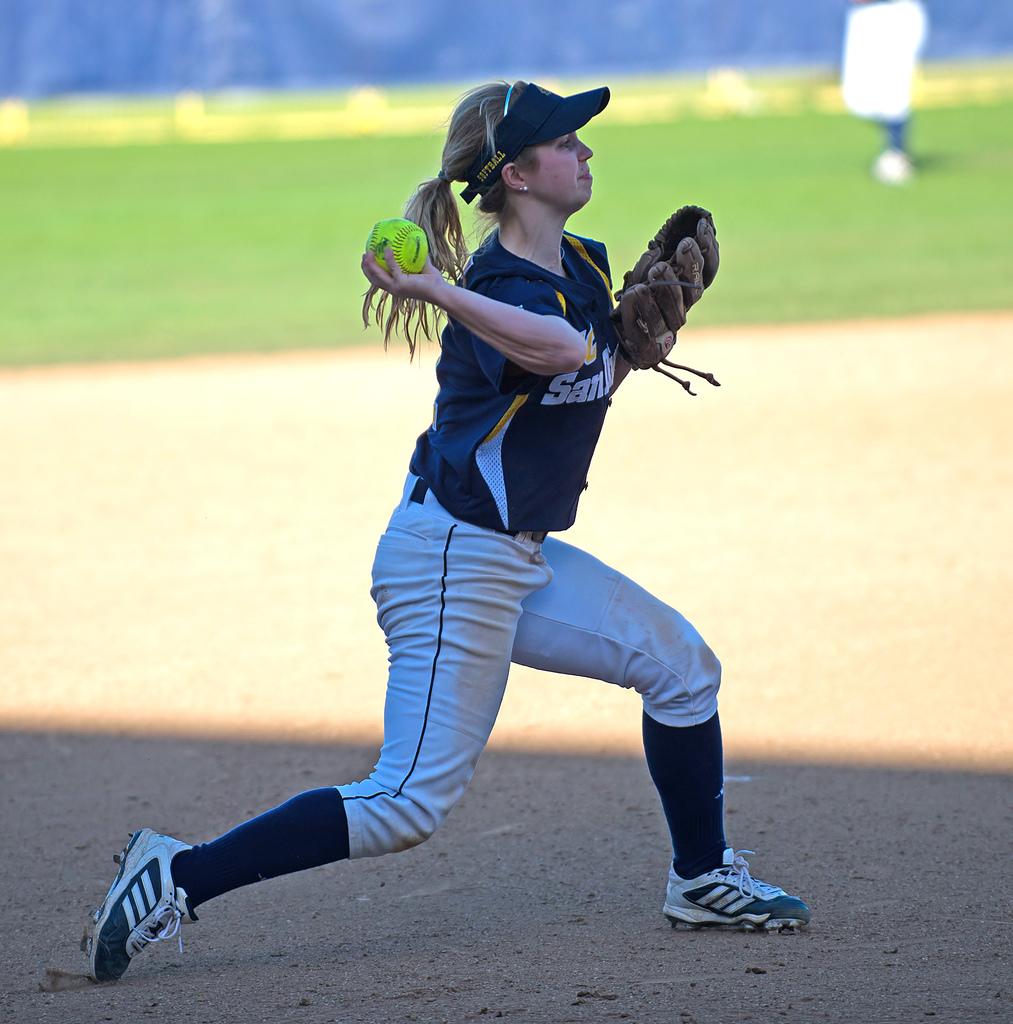What is this girl playing?
Your answer should be compact. Answering does not require reading text in the image. What does the hat say?
Your answer should be compact. Softball. 